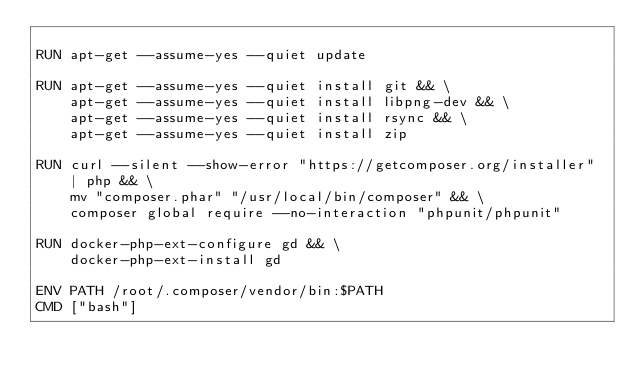<code> <loc_0><loc_0><loc_500><loc_500><_Dockerfile_>
RUN apt-get --assume-yes --quiet update

RUN apt-get --assume-yes --quiet install git && \
    apt-get --assume-yes --quiet install libpng-dev && \
    apt-get --assume-yes --quiet install rsync && \
    apt-get --assume-yes --quiet install zip

RUN curl --silent --show-error "https://getcomposer.org/installer" | php && \
    mv "composer.phar" "/usr/local/bin/composer" && \
    composer global require --no-interaction "phpunit/phpunit"

RUN docker-php-ext-configure gd && \
    docker-php-ext-install gd

ENV PATH /root/.composer/vendor/bin:$PATH
CMD ["bash"]
</code> 